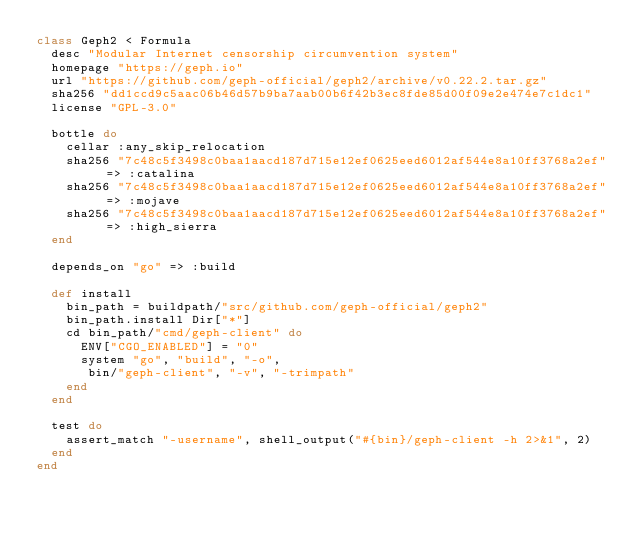<code> <loc_0><loc_0><loc_500><loc_500><_Ruby_>class Geph2 < Formula
  desc "Modular Internet censorship circumvention system"
  homepage "https://geph.io"
  url "https://github.com/geph-official/geph2/archive/v0.22.2.tar.gz"
  sha256 "dd1ccd9c5aac06b46d57b9ba7aab00b6f42b3ec8fde85d00f09e2e474e7c1dc1"
  license "GPL-3.0"

  bottle do
    cellar :any_skip_relocation
    sha256 "7c48c5f3498c0baa1aacd187d715e12ef0625eed6012af544e8a10ff3768a2ef" => :catalina
    sha256 "7c48c5f3498c0baa1aacd187d715e12ef0625eed6012af544e8a10ff3768a2ef" => :mojave
    sha256 "7c48c5f3498c0baa1aacd187d715e12ef0625eed6012af544e8a10ff3768a2ef" => :high_sierra
  end

  depends_on "go" => :build

  def install
    bin_path = buildpath/"src/github.com/geph-official/geph2"
    bin_path.install Dir["*"]
    cd bin_path/"cmd/geph-client" do
      ENV["CGO_ENABLED"] = "0"
      system "go", "build", "-o",
       bin/"geph-client", "-v", "-trimpath"
    end
  end

  test do
    assert_match "-username", shell_output("#{bin}/geph-client -h 2>&1", 2)
  end
end
</code> 